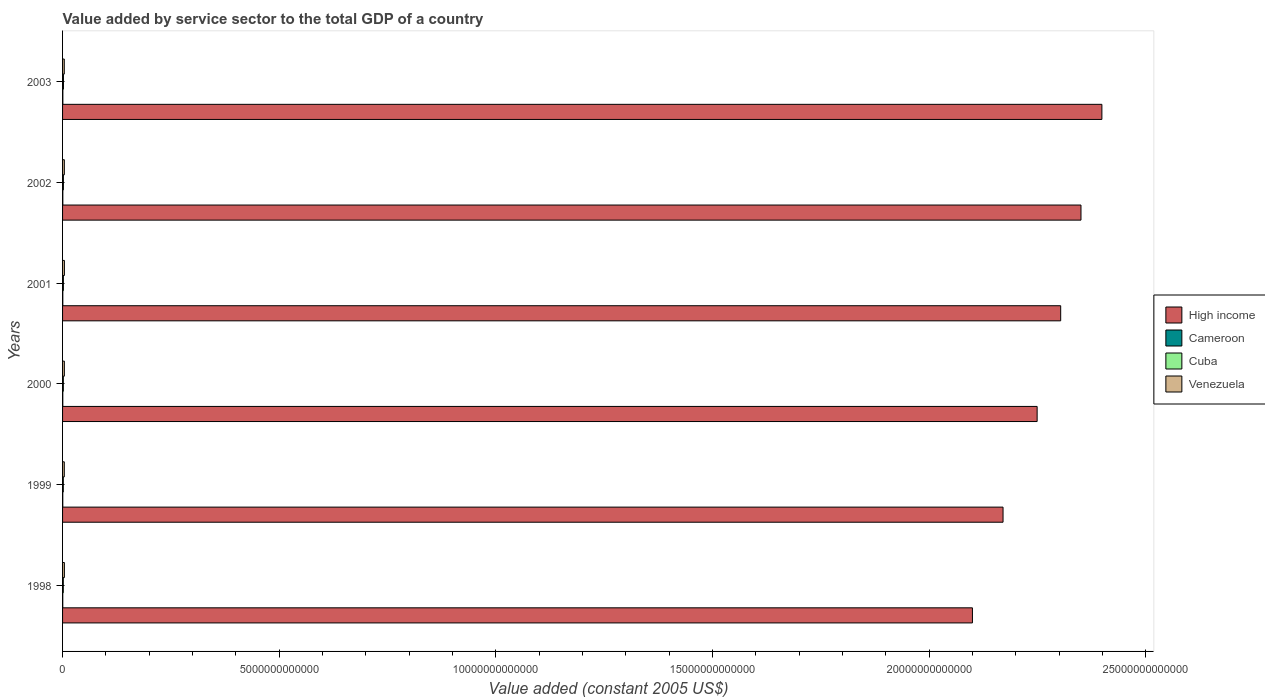How many different coloured bars are there?
Your answer should be compact. 4. How many groups of bars are there?
Provide a succinct answer. 6. Are the number of bars per tick equal to the number of legend labels?
Make the answer very short. Yes. How many bars are there on the 1st tick from the top?
Offer a terse response. 4. What is the label of the 4th group of bars from the top?
Your answer should be very brief. 2000. In how many cases, is the number of bars for a given year not equal to the number of legend labels?
Provide a short and direct response. 0. What is the value added by service sector in Venezuela in 2000?
Keep it short and to the point. 4.14e+1. Across all years, what is the maximum value added by service sector in Cuba?
Ensure brevity in your answer.  2.06e+1. Across all years, what is the minimum value added by service sector in Venezuela?
Your answer should be very brief. 3.95e+1. In which year was the value added by service sector in High income maximum?
Keep it short and to the point. 2003. In which year was the value added by service sector in Cuba minimum?
Your answer should be compact. 1998. What is the total value added by service sector in High income in the graph?
Give a very brief answer. 1.36e+14. What is the difference between the value added by service sector in Cuba in 2002 and that in 2003?
Your answer should be compact. -1.16e+09. What is the difference between the value added by service sector in Venezuela in 2003 and the value added by service sector in Cameroon in 2002?
Your answer should be very brief. 3.33e+1. What is the average value added by service sector in Cameroon per year?
Provide a succinct answer. 5.56e+09. In the year 2003, what is the difference between the value added by service sector in Cameroon and value added by service sector in Cuba?
Provide a short and direct response. -1.40e+1. In how many years, is the value added by service sector in Cuba greater than 5000000000000 US$?
Keep it short and to the point. 0. What is the ratio of the value added by service sector in Venezuela in 1998 to that in 1999?
Provide a short and direct response. 1.05. What is the difference between the highest and the second highest value added by service sector in Cuba?
Your answer should be compact. 1.16e+09. What is the difference between the highest and the lowest value added by service sector in Cuba?
Your response must be concise. 3.88e+09. Is it the case that in every year, the sum of the value added by service sector in Cameroon and value added by service sector in Cuba is greater than the sum of value added by service sector in Venezuela and value added by service sector in High income?
Provide a succinct answer. No. What does the 2nd bar from the top in 2000 represents?
Provide a short and direct response. Cuba. What does the 2nd bar from the bottom in 2000 represents?
Your response must be concise. Cameroon. Is it the case that in every year, the sum of the value added by service sector in Venezuela and value added by service sector in Cuba is greater than the value added by service sector in High income?
Your answer should be compact. No. How many bars are there?
Ensure brevity in your answer.  24. How many years are there in the graph?
Your answer should be compact. 6. What is the difference between two consecutive major ticks on the X-axis?
Offer a terse response. 5.00e+12. Does the graph contain any zero values?
Your answer should be compact. No. Does the graph contain grids?
Provide a short and direct response. No. How many legend labels are there?
Offer a very short reply. 4. What is the title of the graph?
Your answer should be very brief. Value added by service sector to the total GDP of a country. What is the label or title of the X-axis?
Make the answer very short. Value added (constant 2005 US$). What is the label or title of the Y-axis?
Offer a very short reply. Years. What is the Value added (constant 2005 US$) in High income in 1998?
Your answer should be very brief. 2.10e+13. What is the Value added (constant 2005 US$) of Cameroon in 1998?
Offer a very short reply. 4.67e+09. What is the Value added (constant 2005 US$) of Cuba in 1998?
Provide a short and direct response. 1.68e+1. What is the Value added (constant 2005 US$) in Venezuela in 1998?
Your answer should be very brief. 4.20e+1. What is the Value added (constant 2005 US$) in High income in 1999?
Give a very brief answer. 2.17e+13. What is the Value added (constant 2005 US$) of Cameroon in 1999?
Offer a terse response. 4.86e+09. What is the Value added (constant 2005 US$) in Cuba in 1999?
Provide a short and direct response. 1.71e+1. What is the Value added (constant 2005 US$) of Venezuela in 1999?
Provide a succinct answer. 4.00e+1. What is the Value added (constant 2005 US$) in High income in 2000?
Ensure brevity in your answer.  2.25e+13. What is the Value added (constant 2005 US$) of Cameroon in 2000?
Your response must be concise. 5.30e+09. What is the Value added (constant 2005 US$) of Cuba in 2000?
Your answer should be very brief. 1.79e+1. What is the Value added (constant 2005 US$) of Venezuela in 2000?
Give a very brief answer. 4.14e+1. What is the Value added (constant 2005 US$) in High income in 2001?
Your answer should be compact. 2.30e+13. What is the Value added (constant 2005 US$) in Cameroon in 2001?
Provide a succinct answer. 5.75e+09. What is the Value added (constant 2005 US$) in Cuba in 2001?
Your answer should be compact. 1.90e+1. What is the Value added (constant 2005 US$) in Venezuela in 2001?
Provide a short and direct response. 4.26e+1. What is the Value added (constant 2005 US$) of High income in 2002?
Make the answer very short. 2.35e+13. What is the Value added (constant 2005 US$) of Cameroon in 2002?
Make the answer very short. 6.16e+09. What is the Value added (constant 2005 US$) of Cuba in 2002?
Ensure brevity in your answer.  1.95e+1. What is the Value added (constant 2005 US$) of Venezuela in 2002?
Keep it short and to the point. 4.09e+1. What is the Value added (constant 2005 US$) in High income in 2003?
Keep it short and to the point. 2.40e+13. What is the Value added (constant 2005 US$) in Cameroon in 2003?
Your answer should be compact. 6.62e+09. What is the Value added (constant 2005 US$) in Cuba in 2003?
Your response must be concise. 2.06e+1. What is the Value added (constant 2005 US$) of Venezuela in 2003?
Offer a terse response. 3.95e+1. Across all years, what is the maximum Value added (constant 2005 US$) in High income?
Your answer should be compact. 2.40e+13. Across all years, what is the maximum Value added (constant 2005 US$) in Cameroon?
Ensure brevity in your answer.  6.62e+09. Across all years, what is the maximum Value added (constant 2005 US$) of Cuba?
Your answer should be compact. 2.06e+1. Across all years, what is the maximum Value added (constant 2005 US$) of Venezuela?
Offer a terse response. 4.26e+1. Across all years, what is the minimum Value added (constant 2005 US$) in High income?
Make the answer very short. 2.10e+13. Across all years, what is the minimum Value added (constant 2005 US$) of Cameroon?
Your answer should be very brief. 4.67e+09. Across all years, what is the minimum Value added (constant 2005 US$) in Cuba?
Your response must be concise. 1.68e+1. Across all years, what is the minimum Value added (constant 2005 US$) of Venezuela?
Provide a short and direct response. 3.95e+1. What is the total Value added (constant 2005 US$) in High income in the graph?
Your response must be concise. 1.36e+14. What is the total Value added (constant 2005 US$) in Cameroon in the graph?
Offer a very short reply. 3.34e+1. What is the total Value added (constant 2005 US$) of Cuba in the graph?
Ensure brevity in your answer.  1.11e+11. What is the total Value added (constant 2005 US$) in Venezuela in the graph?
Your answer should be compact. 2.46e+11. What is the difference between the Value added (constant 2005 US$) in High income in 1998 and that in 1999?
Keep it short and to the point. -7.06e+11. What is the difference between the Value added (constant 2005 US$) of Cameroon in 1998 and that in 1999?
Ensure brevity in your answer.  -1.91e+08. What is the difference between the Value added (constant 2005 US$) in Cuba in 1998 and that in 1999?
Make the answer very short. -3.54e+08. What is the difference between the Value added (constant 2005 US$) in Venezuela in 1998 and that in 1999?
Give a very brief answer. 2.03e+09. What is the difference between the Value added (constant 2005 US$) of High income in 1998 and that in 2000?
Offer a very short reply. -1.49e+12. What is the difference between the Value added (constant 2005 US$) of Cameroon in 1998 and that in 2000?
Give a very brief answer. -6.29e+08. What is the difference between the Value added (constant 2005 US$) of Cuba in 1998 and that in 2000?
Your response must be concise. -1.14e+09. What is the difference between the Value added (constant 2005 US$) in Venezuela in 1998 and that in 2000?
Keep it short and to the point. 6.67e+08. What is the difference between the Value added (constant 2005 US$) in High income in 1998 and that in 2001?
Your answer should be compact. -2.04e+12. What is the difference between the Value added (constant 2005 US$) in Cameroon in 1998 and that in 2001?
Make the answer very short. -1.08e+09. What is the difference between the Value added (constant 2005 US$) of Cuba in 1998 and that in 2001?
Provide a succinct answer. -2.22e+09. What is the difference between the Value added (constant 2005 US$) in Venezuela in 1998 and that in 2001?
Make the answer very short. -5.10e+08. What is the difference between the Value added (constant 2005 US$) of High income in 1998 and that in 2002?
Your answer should be compact. -2.51e+12. What is the difference between the Value added (constant 2005 US$) of Cameroon in 1998 and that in 2002?
Ensure brevity in your answer.  -1.50e+09. What is the difference between the Value added (constant 2005 US$) in Cuba in 1998 and that in 2002?
Offer a terse response. -2.72e+09. What is the difference between the Value added (constant 2005 US$) of Venezuela in 1998 and that in 2002?
Give a very brief answer. 1.11e+09. What is the difference between the Value added (constant 2005 US$) in High income in 1998 and that in 2003?
Your answer should be compact. -2.99e+12. What is the difference between the Value added (constant 2005 US$) in Cameroon in 1998 and that in 2003?
Keep it short and to the point. -1.95e+09. What is the difference between the Value added (constant 2005 US$) of Cuba in 1998 and that in 2003?
Keep it short and to the point. -3.88e+09. What is the difference between the Value added (constant 2005 US$) of Venezuela in 1998 and that in 2003?
Ensure brevity in your answer.  2.58e+09. What is the difference between the Value added (constant 2005 US$) in High income in 1999 and that in 2000?
Your answer should be compact. -7.87e+11. What is the difference between the Value added (constant 2005 US$) in Cameroon in 1999 and that in 2000?
Offer a very short reply. -4.38e+08. What is the difference between the Value added (constant 2005 US$) of Cuba in 1999 and that in 2000?
Make the answer very short. -7.83e+08. What is the difference between the Value added (constant 2005 US$) of Venezuela in 1999 and that in 2000?
Ensure brevity in your answer.  -1.36e+09. What is the difference between the Value added (constant 2005 US$) in High income in 1999 and that in 2001?
Your answer should be very brief. -1.33e+12. What is the difference between the Value added (constant 2005 US$) in Cameroon in 1999 and that in 2001?
Your response must be concise. -8.87e+08. What is the difference between the Value added (constant 2005 US$) of Cuba in 1999 and that in 2001?
Provide a short and direct response. -1.86e+09. What is the difference between the Value added (constant 2005 US$) in Venezuela in 1999 and that in 2001?
Provide a short and direct response. -2.54e+09. What is the difference between the Value added (constant 2005 US$) of High income in 1999 and that in 2002?
Ensure brevity in your answer.  -1.80e+12. What is the difference between the Value added (constant 2005 US$) of Cameroon in 1999 and that in 2002?
Offer a very short reply. -1.30e+09. What is the difference between the Value added (constant 2005 US$) of Cuba in 1999 and that in 2002?
Offer a very short reply. -2.37e+09. What is the difference between the Value added (constant 2005 US$) of Venezuela in 1999 and that in 2002?
Keep it short and to the point. -9.15e+08. What is the difference between the Value added (constant 2005 US$) of High income in 1999 and that in 2003?
Offer a very short reply. -2.28e+12. What is the difference between the Value added (constant 2005 US$) of Cameroon in 1999 and that in 2003?
Provide a succinct answer. -1.76e+09. What is the difference between the Value added (constant 2005 US$) in Cuba in 1999 and that in 2003?
Make the answer very short. -3.53e+09. What is the difference between the Value added (constant 2005 US$) in Venezuela in 1999 and that in 2003?
Give a very brief answer. 5.56e+08. What is the difference between the Value added (constant 2005 US$) of High income in 2000 and that in 2001?
Provide a succinct answer. -5.44e+11. What is the difference between the Value added (constant 2005 US$) in Cameroon in 2000 and that in 2001?
Ensure brevity in your answer.  -4.49e+08. What is the difference between the Value added (constant 2005 US$) in Cuba in 2000 and that in 2001?
Offer a very short reply. -1.08e+09. What is the difference between the Value added (constant 2005 US$) of Venezuela in 2000 and that in 2001?
Offer a terse response. -1.18e+09. What is the difference between the Value added (constant 2005 US$) of High income in 2000 and that in 2002?
Provide a short and direct response. -1.01e+12. What is the difference between the Value added (constant 2005 US$) in Cameroon in 2000 and that in 2002?
Your answer should be compact. -8.67e+08. What is the difference between the Value added (constant 2005 US$) in Cuba in 2000 and that in 2002?
Provide a succinct answer. -1.59e+09. What is the difference between the Value added (constant 2005 US$) of Venezuela in 2000 and that in 2002?
Your answer should be compact. 4.44e+08. What is the difference between the Value added (constant 2005 US$) in High income in 2000 and that in 2003?
Provide a succinct answer. -1.49e+12. What is the difference between the Value added (constant 2005 US$) in Cameroon in 2000 and that in 2003?
Offer a terse response. -1.32e+09. What is the difference between the Value added (constant 2005 US$) of Cuba in 2000 and that in 2003?
Offer a very short reply. -2.75e+09. What is the difference between the Value added (constant 2005 US$) of Venezuela in 2000 and that in 2003?
Offer a terse response. 1.91e+09. What is the difference between the Value added (constant 2005 US$) in High income in 2001 and that in 2002?
Ensure brevity in your answer.  -4.69e+11. What is the difference between the Value added (constant 2005 US$) in Cameroon in 2001 and that in 2002?
Your answer should be compact. -4.17e+08. What is the difference between the Value added (constant 2005 US$) in Cuba in 2001 and that in 2002?
Ensure brevity in your answer.  -5.08e+08. What is the difference between the Value added (constant 2005 US$) in Venezuela in 2001 and that in 2002?
Your answer should be very brief. 1.62e+09. What is the difference between the Value added (constant 2005 US$) of High income in 2001 and that in 2003?
Keep it short and to the point. -9.51e+11. What is the difference between the Value added (constant 2005 US$) of Cameroon in 2001 and that in 2003?
Ensure brevity in your answer.  -8.71e+08. What is the difference between the Value added (constant 2005 US$) of Cuba in 2001 and that in 2003?
Provide a succinct answer. -1.67e+09. What is the difference between the Value added (constant 2005 US$) of Venezuela in 2001 and that in 2003?
Provide a short and direct response. 3.09e+09. What is the difference between the Value added (constant 2005 US$) of High income in 2002 and that in 2003?
Provide a succinct answer. -4.83e+11. What is the difference between the Value added (constant 2005 US$) of Cameroon in 2002 and that in 2003?
Provide a succinct answer. -4.54e+08. What is the difference between the Value added (constant 2005 US$) of Cuba in 2002 and that in 2003?
Give a very brief answer. -1.16e+09. What is the difference between the Value added (constant 2005 US$) of Venezuela in 2002 and that in 2003?
Provide a succinct answer. 1.47e+09. What is the difference between the Value added (constant 2005 US$) of High income in 1998 and the Value added (constant 2005 US$) of Cameroon in 1999?
Your answer should be very brief. 2.10e+13. What is the difference between the Value added (constant 2005 US$) of High income in 1998 and the Value added (constant 2005 US$) of Cuba in 1999?
Your response must be concise. 2.10e+13. What is the difference between the Value added (constant 2005 US$) in High income in 1998 and the Value added (constant 2005 US$) in Venezuela in 1999?
Your answer should be compact. 2.10e+13. What is the difference between the Value added (constant 2005 US$) of Cameroon in 1998 and the Value added (constant 2005 US$) of Cuba in 1999?
Provide a short and direct response. -1.24e+1. What is the difference between the Value added (constant 2005 US$) in Cameroon in 1998 and the Value added (constant 2005 US$) in Venezuela in 1999?
Keep it short and to the point. -3.54e+1. What is the difference between the Value added (constant 2005 US$) of Cuba in 1998 and the Value added (constant 2005 US$) of Venezuela in 1999?
Offer a terse response. -2.33e+1. What is the difference between the Value added (constant 2005 US$) of High income in 1998 and the Value added (constant 2005 US$) of Cameroon in 2000?
Provide a succinct answer. 2.10e+13. What is the difference between the Value added (constant 2005 US$) in High income in 1998 and the Value added (constant 2005 US$) in Cuba in 2000?
Your answer should be compact. 2.10e+13. What is the difference between the Value added (constant 2005 US$) of High income in 1998 and the Value added (constant 2005 US$) of Venezuela in 2000?
Ensure brevity in your answer.  2.10e+13. What is the difference between the Value added (constant 2005 US$) in Cameroon in 1998 and the Value added (constant 2005 US$) in Cuba in 2000?
Provide a succinct answer. -1.32e+1. What is the difference between the Value added (constant 2005 US$) of Cameroon in 1998 and the Value added (constant 2005 US$) of Venezuela in 2000?
Offer a very short reply. -3.67e+1. What is the difference between the Value added (constant 2005 US$) of Cuba in 1998 and the Value added (constant 2005 US$) of Venezuela in 2000?
Make the answer very short. -2.46e+1. What is the difference between the Value added (constant 2005 US$) of High income in 1998 and the Value added (constant 2005 US$) of Cameroon in 2001?
Keep it short and to the point. 2.10e+13. What is the difference between the Value added (constant 2005 US$) of High income in 1998 and the Value added (constant 2005 US$) of Cuba in 2001?
Your response must be concise. 2.10e+13. What is the difference between the Value added (constant 2005 US$) in High income in 1998 and the Value added (constant 2005 US$) in Venezuela in 2001?
Offer a terse response. 2.10e+13. What is the difference between the Value added (constant 2005 US$) of Cameroon in 1998 and the Value added (constant 2005 US$) of Cuba in 2001?
Give a very brief answer. -1.43e+1. What is the difference between the Value added (constant 2005 US$) in Cameroon in 1998 and the Value added (constant 2005 US$) in Venezuela in 2001?
Provide a succinct answer. -3.79e+1. What is the difference between the Value added (constant 2005 US$) in Cuba in 1998 and the Value added (constant 2005 US$) in Venezuela in 2001?
Give a very brief answer. -2.58e+1. What is the difference between the Value added (constant 2005 US$) in High income in 1998 and the Value added (constant 2005 US$) in Cameroon in 2002?
Your answer should be very brief. 2.10e+13. What is the difference between the Value added (constant 2005 US$) of High income in 1998 and the Value added (constant 2005 US$) of Cuba in 2002?
Give a very brief answer. 2.10e+13. What is the difference between the Value added (constant 2005 US$) in High income in 1998 and the Value added (constant 2005 US$) in Venezuela in 2002?
Your answer should be compact. 2.10e+13. What is the difference between the Value added (constant 2005 US$) in Cameroon in 1998 and the Value added (constant 2005 US$) in Cuba in 2002?
Keep it short and to the point. -1.48e+1. What is the difference between the Value added (constant 2005 US$) of Cameroon in 1998 and the Value added (constant 2005 US$) of Venezuela in 2002?
Give a very brief answer. -3.63e+1. What is the difference between the Value added (constant 2005 US$) of Cuba in 1998 and the Value added (constant 2005 US$) of Venezuela in 2002?
Ensure brevity in your answer.  -2.42e+1. What is the difference between the Value added (constant 2005 US$) in High income in 1998 and the Value added (constant 2005 US$) in Cameroon in 2003?
Make the answer very short. 2.10e+13. What is the difference between the Value added (constant 2005 US$) in High income in 1998 and the Value added (constant 2005 US$) in Cuba in 2003?
Ensure brevity in your answer.  2.10e+13. What is the difference between the Value added (constant 2005 US$) of High income in 1998 and the Value added (constant 2005 US$) of Venezuela in 2003?
Your response must be concise. 2.10e+13. What is the difference between the Value added (constant 2005 US$) of Cameroon in 1998 and the Value added (constant 2005 US$) of Cuba in 2003?
Keep it short and to the point. -1.60e+1. What is the difference between the Value added (constant 2005 US$) of Cameroon in 1998 and the Value added (constant 2005 US$) of Venezuela in 2003?
Make the answer very short. -3.48e+1. What is the difference between the Value added (constant 2005 US$) in Cuba in 1998 and the Value added (constant 2005 US$) in Venezuela in 2003?
Ensure brevity in your answer.  -2.27e+1. What is the difference between the Value added (constant 2005 US$) in High income in 1999 and the Value added (constant 2005 US$) in Cameroon in 2000?
Your response must be concise. 2.17e+13. What is the difference between the Value added (constant 2005 US$) in High income in 1999 and the Value added (constant 2005 US$) in Cuba in 2000?
Your response must be concise. 2.17e+13. What is the difference between the Value added (constant 2005 US$) in High income in 1999 and the Value added (constant 2005 US$) in Venezuela in 2000?
Provide a short and direct response. 2.17e+13. What is the difference between the Value added (constant 2005 US$) of Cameroon in 1999 and the Value added (constant 2005 US$) of Cuba in 2000?
Ensure brevity in your answer.  -1.30e+1. What is the difference between the Value added (constant 2005 US$) of Cameroon in 1999 and the Value added (constant 2005 US$) of Venezuela in 2000?
Keep it short and to the point. -3.65e+1. What is the difference between the Value added (constant 2005 US$) of Cuba in 1999 and the Value added (constant 2005 US$) of Venezuela in 2000?
Your answer should be compact. -2.43e+1. What is the difference between the Value added (constant 2005 US$) in High income in 1999 and the Value added (constant 2005 US$) in Cameroon in 2001?
Offer a very short reply. 2.17e+13. What is the difference between the Value added (constant 2005 US$) of High income in 1999 and the Value added (constant 2005 US$) of Cuba in 2001?
Give a very brief answer. 2.17e+13. What is the difference between the Value added (constant 2005 US$) of High income in 1999 and the Value added (constant 2005 US$) of Venezuela in 2001?
Give a very brief answer. 2.17e+13. What is the difference between the Value added (constant 2005 US$) in Cameroon in 1999 and the Value added (constant 2005 US$) in Cuba in 2001?
Offer a terse response. -1.41e+1. What is the difference between the Value added (constant 2005 US$) of Cameroon in 1999 and the Value added (constant 2005 US$) of Venezuela in 2001?
Your response must be concise. -3.77e+1. What is the difference between the Value added (constant 2005 US$) in Cuba in 1999 and the Value added (constant 2005 US$) in Venezuela in 2001?
Provide a succinct answer. -2.54e+1. What is the difference between the Value added (constant 2005 US$) of High income in 1999 and the Value added (constant 2005 US$) of Cameroon in 2002?
Ensure brevity in your answer.  2.17e+13. What is the difference between the Value added (constant 2005 US$) in High income in 1999 and the Value added (constant 2005 US$) in Cuba in 2002?
Offer a terse response. 2.17e+13. What is the difference between the Value added (constant 2005 US$) in High income in 1999 and the Value added (constant 2005 US$) in Venezuela in 2002?
Offer a terse response. 2.17e+13. What is the difference between the Value added (constant 2005 US$) of Cameroon in 1999 and the Value added (constant 2005 US$) of Cuba in 2002?
Keep it short and to the point. -1.46e+1. What is the difference between the Value added (constant 2005 US$) of Cameroon in 1999 and the Value added (constant 2005 US$) of Venezuela in 2002?
Your response must be concise. -3.61e+1. What is the difference between the Value added (constant 2005 US$) of Cuba in 1999 and the Value added (constant 2005 US$) of Venezuela in 2002?
Provide a short and direct response. -2.38e+1. What is the difference between the Value added (constant 2005 US$) in High income in 1999 and the Value added (constant 2005 US$) in Cameroon in 2003?
Give a very brief answer. 2.17e+13. What is the difference between the Value added (constant 2005 US$) of High income in 1999 and the Value added (constant 2005 US$) of Cuba in 2003?
Your answer should be compact. 2.17e+13. What is the difference between the Value added (constant 2005 US$) of High income in 1999 and the Value added (constant 2005 US$) of Venezuela in 2003?
Offer a terse response. 2.17e+13. What is the difference between the Value added (constant 2005 US$) of Cameroon in 1999 and the Value added (constant 2005 US$) of Cuba in 2003?
Your answer should be very brief. -1.58e+1. What is the difference between the Value added (constant 2005 US$) of Cameroon in 1999 and the Value added (constant 2005 US$) of Venezuela in 2003?
Offer a very short reply. -3.46e+1. What is the difference between the Value added (constant 2005 US$) of Cuba in 1999 and the Value added (constant 2005 US$) of Venezuela in 2003?
Offer a terse response. -2.24e+1. What is the difference between the Value added (constant 2005 US$) in High income in 2000 and the Value added (constant 2005 US$) in Cameroon in 2001?
Make the answer very short. 2.25e+13. What is the difference between the Value added (constant 2005 US$) in High income in 2000 and the Value added (constant 2005 US$) in Cuba in 2001?
Ensure brevity in your answer.  2.25e+13. What is the difference between the Value added (constant 2005 US$) of High income in 2000 and the Value added (constant 2005 US$) of Venezuela in 2001?
Provide a short and direct response. 2.25e+13. What is the difference between the Value added (constant 2005 US$) in Cameroon in 2000 and the Value added (constant 2005 US$) in Cuba in 2001?
Keep it short and to the point. -1.37e+1. What is the difference between the Value added (constant 2005 US$) of Cameroon in 2000 and the Value added (constant 2005 US$) of Venezuela in 2001?
Give a very brief answer. -3.73e+1. What is the difference between the Value added (constant 2005 US$) in Cuba in 2000 and the Value added (constant 2005 US$) in Venezuela in 2001?
Your answer should be compact. -2.47e+1. What is the difference between the Value added (constant 2005 US$) of High income in 2000 and the Value added (constant 2005 US$) of Cameroon in 2002?
Provide a short and direct response. 2.25e+13. What is the difference between the Value added (constant 2005 US$) in High income in 2000 and the Value added (constant 2005 US$) in Cuba in 2002?
Your answer should be very brief. 2.25e+13. What is the difference between the Value added (constant 2005 US$) of High income in 2000 and the Value added (constant 2005 US$) of Venezuela in 2002?
Your answer should be very brief. 2.25e+13. What is the difference between the Value added (constant 2005 US$) of Cameroon in 2000 and the Value added (constant 2005 US$) of Cuba in 2002?
Provide a short and direct response. -1.42e+1. What is the difference between the Value added (constant 2005 US$) of Cameroon in 2000 and the Value added (constant 2005 US$) of Venezuela in 2002?
Your answer should be very brief. -3.56e+1. What is the difference between the Value added (constant 2005 US$) in Cuba in 2000 and the Value added (constant 2005 US$) in Venezuela in 2002?
Ensure brevity in your answer.  -2.30e+1. What is the difference between the Value added (constant 2005 US$) in High income in 2000 and the Value added (constant 2005 US$) in Cameroon in 2003?
Keep it short and to the point. 2.25e+13. What is the difference between the Value added (constant 2005 US$) of High income in 2000 and the Value added (constant 2005 US$) of Cuba in 2003?
Offer a terse response. 2.25e+13. What is the difference between the Value added (constant 2005 US$) of High income in 2000 and the Value added (constant 2005 US$) of Venezuela in 2003?
Provide a short and direct response. 2.25e+13. What is the difference between the Value added (constant 2005 US$) in Cameroon in 2000 and the Value added (constant 2005 US$) in Cuba in 2003?
Offer a terse response. -1.53e+1. What is the difference between the Value added (constant 2005 US$) in Cameroon in 2000 and the Value added (constant 2005 US$) in Venezuela in 2003?
Ensure brevity in your answer.  -3.42e+1. What is the difference between the Value added (constant 2005 US$) in Cuba in 2000 and the Value added (constant 2005 US$) in Venezuela in 2003?
Offer a very short reply. -2.16e+1. What is the difference between the Value added (constant 2005 US$) of High income in 2001 and the Value added (constant 2005 US$) of Cameroon in 2002?
Provide a short and direct response. 2.30e+13. What is the difference between the Value added (constant 2005 US$) in High income in 2001 and the Value added (constant 2005 US$) in Cuba in 2002?
Offer a terse response. 2.30e+13. What is the difference between the Value added (constant 2005 US$) in High income in 2001 and the Value added (constant 2005 US$) in Venezuela in 2002?
Offer a terse response. 2.30e+13. What is the difference between the Value added (constant 2005 US$) in Cameroon in 2001 and the Value added (constant 2005 US$) in Cuba in 2002?
Provide a short and direct response. -1.37e+1. What is the difference between the Value added (constant 2005 US$) in Cameroon in 2001 and the Value added (constant 2005 US$) in Venezuela in 2002?
Keep it short and to the point. -3.52e+1. What is the difference between the Value added (constant 2005 US$) of Cuba in 2001 and the Value added (constant 2005 US$) of Venezuela in 2002?
Provide a short and direct response. -2.20e+1. What is the difference between the Value added (constant 2005 US$) in High income in 2001 and the Value added (constant 2005 US$) in Cameroon in 2003?
Make the answer very short. 2.30e+13. What is the difference between the Value added (constant 2005 US$) of High income in 2001 and the Value added (constant 2005 US$) of Cuba in 2003?
Your answer should be compact. 2.30e+13. What is the difference between the Value added (constant 2005 US$) in High income in 2001 and the Value added (constant 2005 US$) in Venezuela in 2003?
Keep it short and to the point. 2.30e+13. What is the difference between the Value added (constant 2005 US$) in Cameroon in 2001 and the Value added (constant 2005 US$) in Cuba in 2003?
Offer a terse response. -1.49e+1. What is the difference between the Value added (constant 2005 US$) in Cameroon in 2001 and the Value added (constant 2005 US$) in Venezuela in 2003?
Provide a short and direct response. -3.37e+1. What is the difference between the Value added (constant 2005 US$) of Cuba in 2001 and the Value added (constant 2005 US$) of Venezuela in 2003?
Offer a very short reply. -2.05e+1. What is the difference between the Value added (constant 2005 US$) of High income in 2002 and the Value added (constant 2005 US$) of Cameroon in 2003?
Make the answer very short. 2.35e+13. What is the difference between the Value added (constant 2005 US$) in High income in 2002 and the Value added (constant 2005 US$) in Cuba in 2003?
Ensure brevity in your answer.  2.35e+13. What is the difference between the Value added (constant 2005 US$) in High income in 2002 and the Value added (constant 2005 US$) in Venezuela in 2003?
Make the answer very short. 2.35e+13. What is the difference between the Value added (constant 2005 US$) in Cameroon in 2002 and the Value added (constant 2005 US$) in Cuba in 2003?
Provide a short and direct response. -1.45e+1. What is the difference between the Value added (constant 2005 US$) in Cameroon in 2002 and the Value added (constant 2005 US$) in Venezuela in 2003?
Offer a very short reply. -3.33e+1. What is the difference between the Value added (constant 2005 US$) in Cuba in 2002 and the Value added (constant 2005 US$) in Venezuela in 2003?
Your response must be concise. -2.00e+1. What is the average Value added (constant 2005 US$) in High income per year?
Offer a terse response. 2.26e+13. What is the average Value added (constant 2005 US$) in Cameroon per year?
Your response must be concise. 5.56e+09. What is the average Value added (constant 2005 US$) of Cuba per year?
Provide a short and direct response. 1.85e+1. What is the average Value added (constant 2005 US$) in Venezuela per year?
Offer a terse response. 4.11e+1. In the year 1998, what is the difference between the Value added (constant 2005 US$) of High income and Value added (constant 2005 US$) of Cameroon?
Provide a short and direct response. 2.10e+13. In the year 1998, what is the difference between the Value added (constant 2005 US$) in High income and Value added (constant 2005 US$) in Cuba?
Your answer should be compact. 2.10e+13. In the year 1998, what is the difference between the Value added (constant 2005 US$) of High income and Value added (constant 2005 US$) of Venezuela?
Your response must be concise. 2.10e+13. In the year 1998, what is the difference between the Value added (constant 2005 US$) in Cameroon and Value added (constant 2005 US$) in Cuba?
Provide a short and direct response. -1.21e+1. In the year 1998, what is the difference between the Value added (constant 2005 US$) in Cameroon and Value added (constant 2005 US$) in Venezuela?
Offer a very short reply. -3.74e+1. In the year 1998, what is the difference between the Value added (constant 2005 US$) in Cuba and Value added (constant 2005 US$) in Venezuela?
Provide a succinct answer. -2.53e+1. In the year 1999, what is the difference between the Value added (constant 2005 US$) in High income and Value added (constant 2005 US$) in Cameroon?
Your response must be concise. 2.17e+13. In the year 1999, what is the difference between the Value added (constant 2005 US$) in High income and Value added (constant 2005 US$) in Cuba?
Make the answer very short. 2.17e+13. In the year 1999, what is the difference between the Value added (constant 2005 US$) of High income and Value added (constant 2005 US$) of Venezuela?
Your response must be concise. 2.17e+13. In the year 1999, what is the difference between the Value added (constant 2005 US$) in Cameroon and Value added (constant 2005 US$) in Cuba?
Provide a short and direct response. -1.23e+1. In the year 1999, what is the difference between the Value added (constant 2005 US$) of Cameroon and Value added (constant 2005 US$) of Venezuela?
Make the answer very short. -3.52e+1. In the year 1999, what is the difference between the Value added (constant 2005 US$) of Cuba and Value added (constant 2005 US$) of Venezuela?
Provide a succinct answer. -2.29e+1. In the year 2000, what is the difference between the Value added (constant 2005 US$) in High income and Value added (constant 2005 US$) in Cameroon?
Your answer should be compact. 2.25e+13. In the year 2000, what is the difference between the Value added (constant 2005 US$) in High income and Value added (constant 2005 US$) in Cuba?
Offer a terse response. 2.25e+13. In the year 2000, what is the difference between the Value added (constant 2005 US$) in High income and Value added (constant 2005 US$) in Venezuela?
Offer a terse response. 2.25e+13. In the year 2000, what is the difference between the Value added (constant 2005 US$) of Cameroon and Value added (constant 2005 US$) of Cuba?
Your response must be concise. -1.26e+1. In the year 2000, what is the difference between the Value added (constant 2005 US$) of Cameroon and Value added (constant 2005 US$) of Venezuela?
Your answer should be very brief. -3.61e+1. In the year 2000, what is the difference between the Value added (constant 2005 US$) in Cuba and Value added (constant 2005 US$) in Venezuela?
Keep it short and to the point. -2.35e+1. In the year 2001, what is the difference between the Value added (constant 2005 US$) in High income and Value added (constant 2005 US$) in Cameroon?
Ensure brevity in your answer.  2.30e+13. In the year 2001, what is the difference between the Value added (constant 2005 US$) in High income and Value added (constant 2005 US$) in Cuba?
Your answer should be compact. 2.30e+13. In the year 2001, what is the difference between the Value added (constant 2005 US$) in High income and Value added (constant 2005 US$) in Venezuela?
Ensure brevity in your answer.  2.30e+13. In the year 2001, what is the difference between the Value added (constant 2005 US$) of Cameroon and Value added (constant 2005 US$) of Cuba?
Provide a succinct answer. -1.32e+1. In the year 2001, what is the difference between the Value added (constant 2005 US$) of Cameroon and Value added (constant 2005 US$) of Venezuela?
Your answer should be compact. -3.68e+1. In the year 2001, what is the difference between the Value added (constant 2005 US$) in Cuba and Value added (constant 2005 US$) in Venezuela?
Provide a succinct answer. -2.36e+1. In the year 2002, what is the difference between the Value added (constant 2005 US$) in High income and Value added (constant 2005 US$) in Cameroon?
Provide a succinct answer. 2.35e+13. In the year 2002, what is the difference between the Value added (constant 2005 US$) of High income and Value added (constant 2005 US$) of Cuba?
Give a very brief answer. 2.35e+13. In the year 2002, what is the difference between the Value added (constant 2005 US$) in High income and Value added (constant 2005 US$) in Venezuela?
Ensure brevity in your answer.  2.35e+13. In the year 2002, what is the difference between the Value added (constant 2005 US$) of Cameroon and Value added (constant 2005 US$) of Cuba?
Your response must be concise. -1.33e+1. In the year 2002, what is the difference between the Value added (constant 2005 US$) in Cameroon and Value added (constant 2005 US$) in Venezuela?
Ensure brevity in your answer.  -3.48e+1. In the year 2002, what is the difference between the Value added (constant 2005 US$) in Cuba and Value added (constant 2005 US$) in Venezuela?
Your answer should be compact. -2.15e+1. In the year 2003, what is the difference between the Value added (constant 2005 US$) in High income and Value added (constant 2005 US$) in Cameroon?
Keep it short and to the point. 2.40e+13. In the year 2003, what is the difference between the Value added (constant 2005 US$) of High income and Value added (constant 2005 US$) of Cuba?
Offer a terse response. 2.40e+13. In the year 2003, what is the difference between the Value added (constant 2005 US$) of High income and Value added (constant 2005 US$) of Venezuela?
Offer a very short reply. 2.39e+13. In the year 2003, what is the difference between the Value added (constant 2005 US$) in Cameroon and Value added (constant 2005 US$) in Cuba?
Provide a short and direct response. -1.40e+1. In the year 2003, what is the difference between the Value added (constant 2005 US$) of Cameroon and Value added (constant 2005 US$) of Venezuela?
Your answer should be very brief. -3.28e+1. In the year 2003, what is the difference between the Value added (constant 2005 US$) in Cuba and Value added (constant 2005 US$) in Venezuela?
Your response must be concise. -1.88e+1. What is the ratio of the Value added (constant 2005 US$) in High income in 1998 to that in 1999?
Provide a short and direct response. 0.97. What is the ratio of the Value added (constant 2005 US$) in Cameroon in 1998 to that in 1999?
Give a very brief answer. 0.96. What is the ratio of the Value added (constant 2005 US$) of Cuba in 1998 to that in 1999?
Offer a very short reply. 0.98. What is the ratio of the Value added (constant 2005 US$) of Venezuela in 1998 to that in 1999?
Your answer should be compact. 1.05. What is the ratio of the Value added (constant 2005 US$) of High income in 1998 to that in 2000?
Provide a succinct answer. 0.93. What is the ratio of the Value added (constant 2005 US$) of Cameroon in 1998 to that in 2000?
Make the answer very short. 0.88. What is the ratio of the Value added (constant 2005 US$) of Cuba in 1998 to that in 2000?
Provide a succinct answer. 0.94. What is the ratio of the Value added (constant 2005 US$) of Venezuela in 1998 to that in 2000?
Offer a terse response. 1.02. What is the ratio of the Value added (constant 2005 US$) in High income in 1998 to that in 2001?
Offer a very short reply. 0.91. What is the ratio of the Value added (constant 2005 US$) of Cameroon in 1998 to that in 2001?
Your response must be concise. 0.81. What is the ratio of the Value added (constant 2005 US$) of Cuba in 1998 to that in 2001?
Offer a terse response. 0.88. What is the ratio of the Value added (constant 2005 US$) of High income in 1998 to that in 2002?
Keep it short and to the point. 0.89. What is the ratio of the Value added (constant 2005 US$) in Cameroon in 1998 to that in 2002?
Give a very brief answer. 0.76. What is the ratio of the Value added (constant 2005 US$) of Cuba in 1998 to that in 2002?
Your response must be concise. 0.86. What is the ratio of the Value added (constant 2005 US$) in Venezuela in 1998 to that in 2002?
Keep it short and to the point. 1.03. What is the ratio of the Value added (constant 2005 US$) of High income in 1998 to that in 2003?
Make the answer very short. 0.88. What is the ratio of the Value added (constant 2005 US$) of Cameroon in 1998 to that in 2003?
Offer a very short reply. 0.71. What is the ratio of the Value added (constant 2005 US$) in Cuba in 1998 to that in 2003?
Your answer should be compact. 0.81. What is the ratio of the Value added (constant 2005 US$) of Venezuela in 1998 to that in 2003?
Your response must be concise. 1.07. What is the ratio of the Value added (constant 2005 US$) of High income in 1999 to that in 2000?
Offer a terse response. 0.96. What is the ratio of the Value added (constant 2005 US$) in Cameroon in 1999 to that in 2000?
Keep it short and to the point. 0.92. What is the ratio of the Value added (constant 2005 US$) of Cuba in 1999 to that in 2000?
Make the answer very short. 0.96. What is the ratio of the Value added (constant 2005 US$) in Venezuela in 1999 to that in 2000?
Your answer should be compact. 0.97. What is the ratio of the Value added (constant 2005 US$) of High income in 1999 to that in 2001?
Make the answer very short. 0.94. What is the ratio of the Value added (constant 2005 US$) in Cameroon in 1999 to that in 2001?
Make the answer very short. 0.85. What is the ratio of the Value added (constant 2005 US$) in Cuba in 1999 to that in 2001?
Provide a short and direct response. 0.9. What is the ratio of the Value added (constant 2005 US$) of Venezuela in 1999 to that in 2001?
Your answer should be compact. 0.94. What is the ratio of the Value added (constant 2005 US$) of High income in 1999 to that in 2002?
Offer a terse response. 0.92. What is the ratio of the Value added (constant 2005 US$) of Cameroon in 1999 to that in 2002?
Your response must be concise. 0.79. What is the ratio of the Value added (constant 2005 US$) in Cuba in 1999 to that in 2002?
Give a very brief answer. 0.88. What is the ratio of the Value added (constant 2005 US$) of Venezuela in 1999 to that in 2002?
Your answer should be compact. 0.98. What is the ratio of the Value added (constant 2005 US$) in High income in 1999 to that in 2003?
Offer a terse response. 0.9. What is the ratio of the Value added (constant 2005 US$) of Cameroon in 1999 to that in 2003?
Your response must be concise. 0.73. What is the ratio of the Value added (constant 2005 US$) of Cuba in 1999 to that in 2003?
Offer a terse response. 0.83. What is the ratio of the Value added (constant 2005 US$) of Venezuela in 1999 to that in 2003?
Provide a succinct answer. 1.01. What is the ratio of the Value added (constant 2005 US$) of High income in 2000 to that in 2001?
Ensure brevity in your answer.  0.98. What is the ratio of the Value added (constant 2005 US$) in Cameroon in 2000 to that in 2001?
Make the answer very short. 0.92. What is the ratio of the Value added (constant 2005 US$) of Cuba in 2000 to that in 2001?
Keep it short and to the point. 0.94. What is the ratio of the Value added (constant 2005 US$) of Venezuela in 2000 to that in 2001?
Your response must be concise. 0.97. What is the ratio of the Value added (constant 2005 US$) of High income in 2000 to that in 2002?
Provide a short and direct response. 0.96. What is the ratio of the Value added (constant 2005 US$) of Cameroon in 2000 to that in 2002?
Your answer should be very brief. 0.86. What is the ratio of the Value added (constant 2005 US$) in Cuba in 2000 to that in 2002?
Keep it short and to the point. 0.92. What is the ratio of the Value added (constant 2005 US$) of Venezuela in 2000 to that in 2002?
Make the answer very short. 1.01. What is the ratio of the Value added (constant 2005 US$) of High income in 2000 to that in 2003?
Provide a short and direct response. 0.94. What is the ratio of the Value added (constant 2005 US$) in Cameroon in 2000 to that in 2003?
Keep it short and to the point. 0.8. What is the ratio of the Value added (constant 2005 US$) of Cuba in 2000 to that in 2003?
Give a very brief answer. 0.87. What is the ratio of the Value added (constant 2005 US$) in Venezuela in 2000 to that in 2003?
Give a very brief answer. 1.05. What is the ratio of the Value added (constant 2005 US$) of High income in 2001 to that in 2002?
Give a very brief answer. 0.98. What is the ratio of the Value added (constant 2005 US$) in Cameroon in 2001 to that in 2002?
Offer a terse response. 0.93. What is the ratio of the Value added (constant 2005 US$) in Cuba in 2001 to that in 2002?
Ensure brevity in your answer.  0.97. What is the ratio of the Value added (constant 2005 US$) of Venezuela in 2001 to that in 2002?
Give a very brief answer. 1.04. What is the ratio of the Value added (constant 2005 US$) of High income in 2001 to that in 2003?
Offer a very short reply. 0.96. What is the ratio of the Value added (constant 2005 US$) of Cameroon in 2001 to that in 2003?
Give a very brief answer. 0.87. What is the ratio of the Value added (constant 2005 US$) in Cuba in 2001 to that in 2003?
Provide a succinct answer. 0.92. What is the ratio of the Value added (constant 2005 US$) in Venezuela in 2001 to that in 2003?
Make the answer very short. 1.08. What is the ratio of the Value added (constant 2005 US$) of High income in 2002 to that in 2003?
Give a very brief answer. 0.98. What is the ratio of the Value added (constant 2005 US$) in Cameroon in 2002 to that in 2003?
Your response must be concise. 0.93. What is the ratio of the Value added (constant 2005 US$) of Cuba in 2002 to that in 2003?
Keep it short and to the point. 0.94. What is the ratio of the Value added (constant 2005 US$) of Venezuela in 2002 to that in 2003?
Make the answer very short. 1.04. What is the difference between the highest and the second highest Value added (constant 2005 US$) of High income?
Your response must be concise. 4.83e+11. What is the difference between the highest and the second highest Value added (constant 2005 US$) of Cameroon?
Your answer should be compact. 4.54e+08. What is the difference between the highest and the second highest Value added (constant 2005 US$) of Cuba?
Keep it short and to the point. 1.16e+09. What is the difference between the highest and the second highest Value added (constant 2005 US$) of Venezuela?
Offer a terse response. 5.10e+08. What is the difference between the highest and the lowest Value added (constant 2005 US$) in High income?
Ensure brevity in your answer.  2.99e+12. What is the difference between the highest and the lowest Value added (constant 2005 US$) in Cameroon?
Provide a succinct answer. 1.95e+09. What is the difference between the highest and the lowest Value added (constant 2005 US$) in Cuba?
Provide a short and direct response. 3.88e+09. What is the difference between the highest and the lowest Value added (constant 2005 US$) of Venezuela?
Provide a short and direct response. 3.09e+09. 